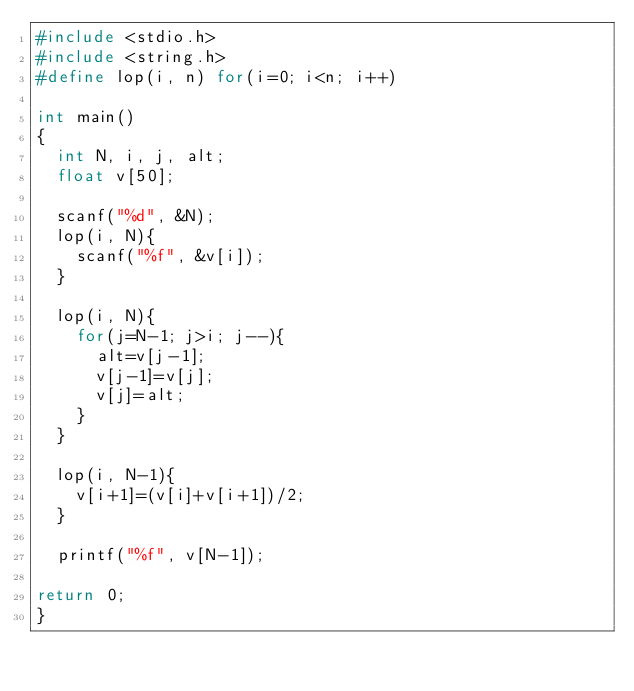Convert code to text. <code><loc_0><loc_0><loc_500><loc_500><_C_>#include <stdio.h>
#include <string.h>
#define lop(i, n) for(i=0; i<n; i++)

int main()
{
	int N, i, j, alt;
	float v[50];
	
	scanf("%d", &N);
	lop(i, N){
		scanf("%f", &v[i]);
	}
	
	lop(i, N){
		for(j=N-1; j>i; j--){
			alt=v[j-1];
			v[j-1]=v[j];
			v[j]=alt;
		}
	}
	
	lop(i, N-1){
		v[i+1]=(v[i]+v[i+1])/2;
	}
	
	printf("%f", v[N-1]);
	
return 0;
}</code> 